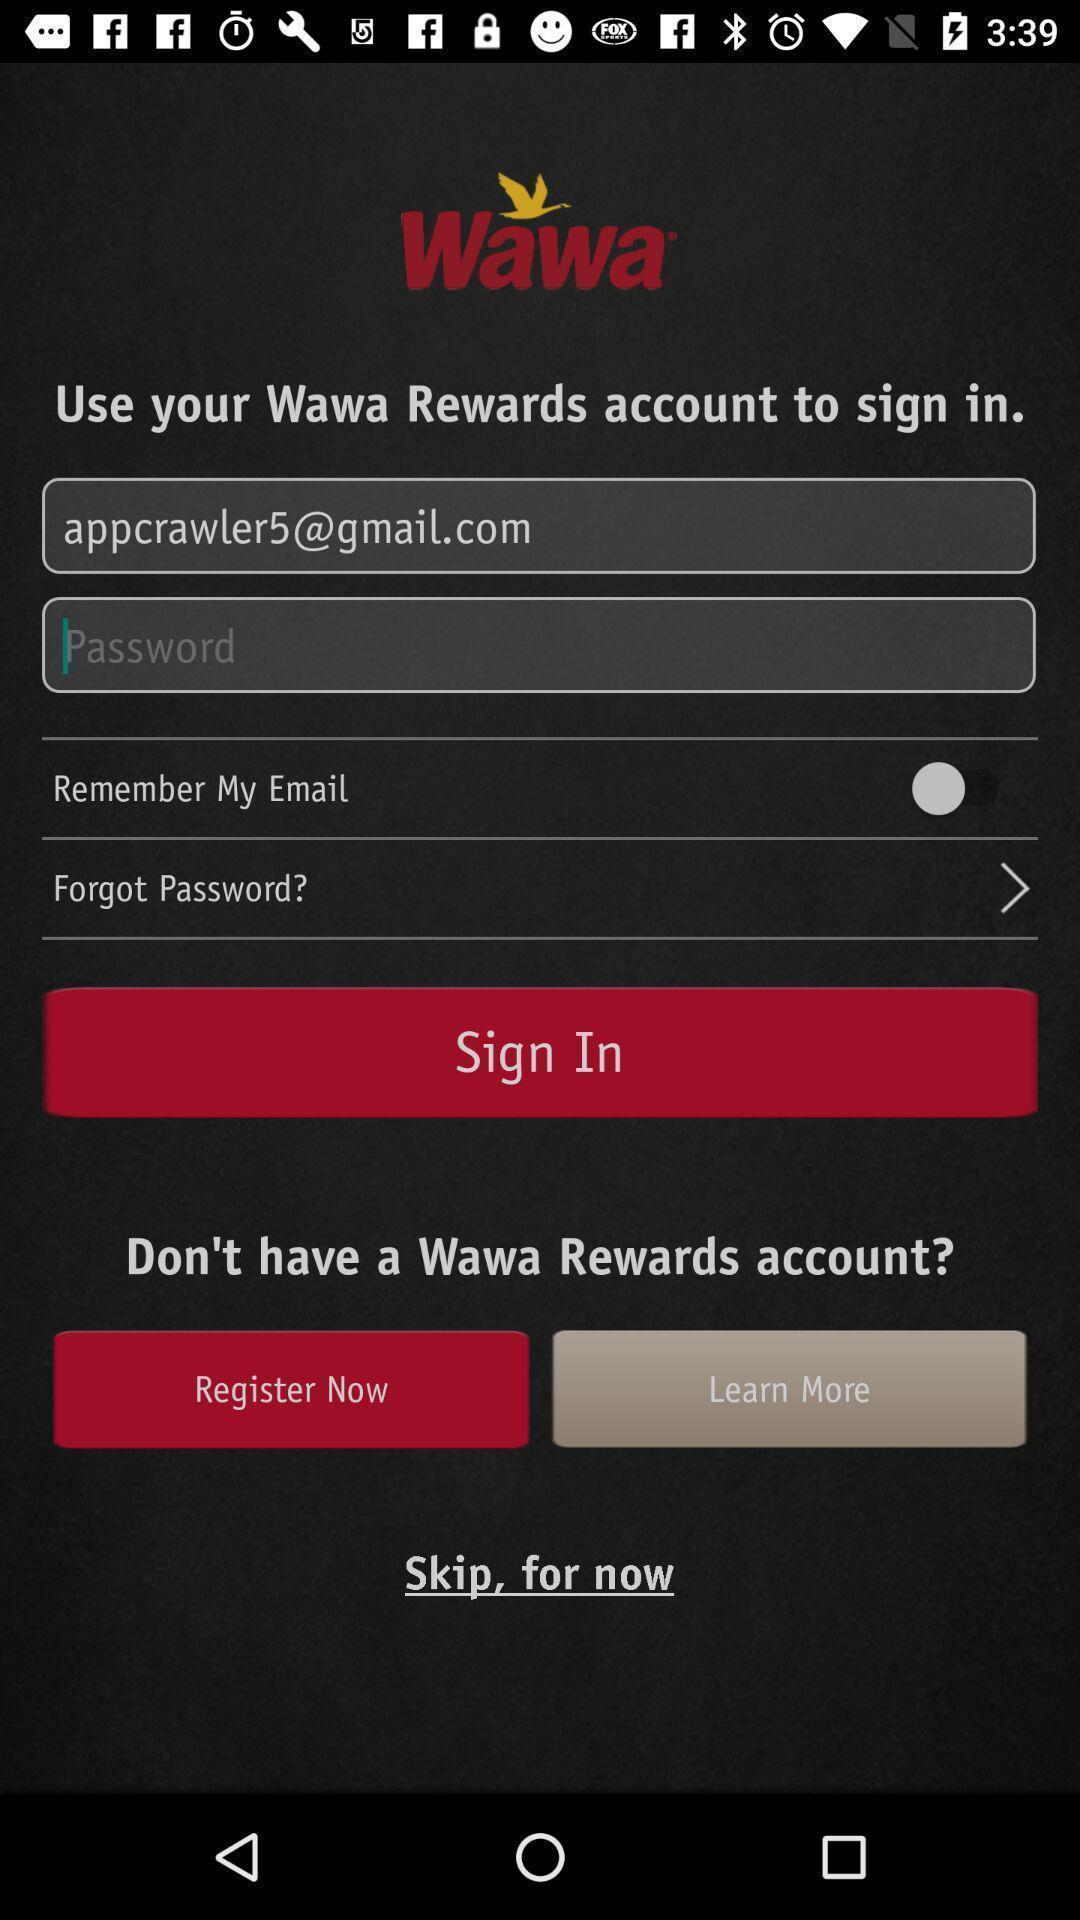What can you discern from this picture? Welcome and log-in page for an application. 